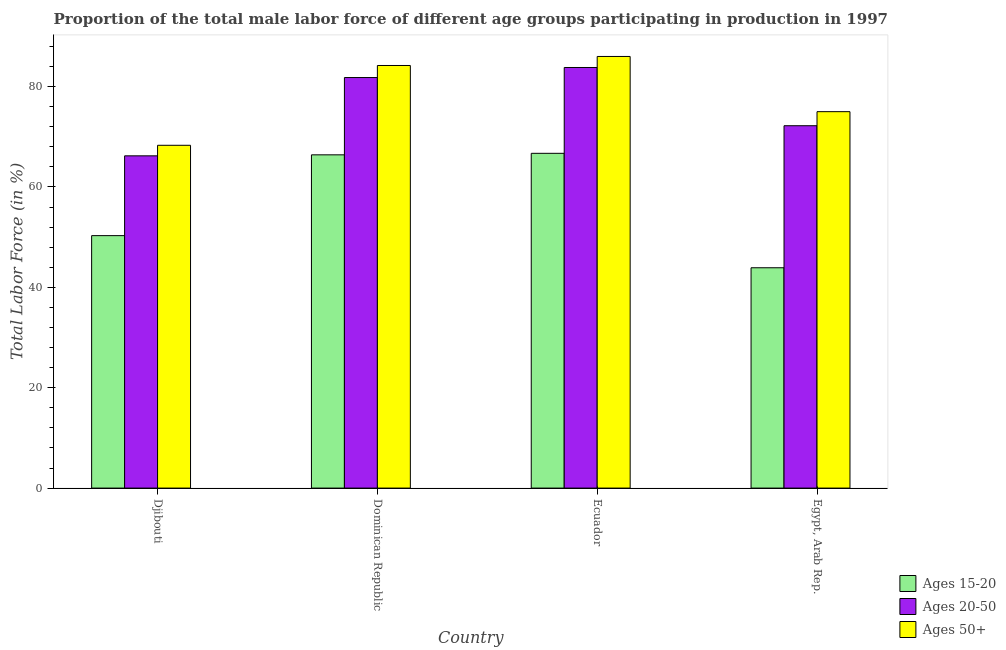How many bars are there on the 1st tick from the right?
Make the answer very short. 3. What is the label of the 1st group of bars from the left?
Provide a short and direct response. Djibouti. In how many cases, is the number of bars for a given country not equal to the number of legend labels?
Keep it short and to the point. 0. What is the percentage of male labor force above age 50 in Dominican Republic?
Ensure brevity in your answer.  84.2. Across all countries, what is the maximum percentage of male labor force within the age group 20-50?
Provide a short and direct response. 83.8. Across all countries, what is the minimum percentage of male labor force above age 50?
Provide a succinct answer. 68.3. In which country was the percentage of male labor force within the age group 15-20 maximum?
Offer a very short reply. Ecuador. In which country was the percentage of male labor force within the age group 20-50 minimum?
Give a very brief answer. Djibouti. What is the total percentage of male labor force within the age group 20-50 in the graph?
Keep it short and to the point. 304. What is the difference between the percentage of male labor force within the age group 15-20 in Ecuador and that in Egypt, Arab Rep.?
Ensure brevity in your answer.  22.8. What is the difference between the percentage of male labor force within the age group 15-20 in Egypt, Arab Rep. and the percentage of male labor force above age 50 in Dominican Republic?
Your response must be concise. -40.3. What is the average percentage of male labor force above age 50 per country?
Offer a very short reply. 78.38. What is the difference between the percentage of male labor force within the age group 15-20 and percentage of male labor force within the age group 20-50 in Ecuador?
Make the answer very short. -17.1. What is the ratio of the percentage of male labor force within the age group 20-50 in Dominican Republic to that in Ecuador?
Ensure brevity in your answer.  0.98. Is the percentage of male labor force above age 50 in Djibouti less than that in Ecuador?
Offer a terse response. Yes. Is the difference between the percentage of male labor force above age 50 in Djibouti and Ecuador greater than the difference between the percentage of male labor force within the age group 15-20 in Djibouti and Ecuador?
Offer a terse response. No. What is the difference between the highest and the second highest percentage of male labor force above age 50?
Provide a succinct answer. 1.8. What is the difference between the highest and the lowest percentage of male labor force within the age group 15-20?
Your response must be concise. 22.8. In how many countries, is the percentage of male labor force within the age group 20-50 greater than the average percentage of male labor force within the age group 20-50 taken over all countries?
Ensure brevity in your answer.  2. What does the 1st bar from the left in Ecuador represents?
Make the answer very short. Ages 15-20. What does the 2nd bar from the right in Ecuador represents?
Your answer should be compact. Ages 20-50. Is it the case that in every country, the sum of the percentage of male labor force within the age group 15-20 and percentage of male labor force within the age group 20-50 is greater than the percentage of male labor force above age 50?
Ensure brevity in your answer.  Yes. How many bars are there?
Your answer should be very brief. 12. How many countries are there in the graph?
Offer a very short reply. 4. What is the difference between two consecutive major ticks on the Y-axis?
Your answer should be very brief. 20. Are the values on the major ticks of Y-axis written in scientific E-notation?
Give a very brief answer. No. Does the graph contain any zero values?
Your response must be concise. No. Where does the legend appear in the graph?
Keep it short and to the point. Bottom right. How are the legend labels stacked?
Ensure brevity in your answer.  Vertical. What is the title of the graph?
Your answer should be very brief. Proportion of the total male labor force of different age groups participating in production in 1997. Does "Central government" appear as one of the legend labels in the graph?
Keep it short and to the point. No. What is the label or title of the X-axis?
Your answer should be compact. Country. What is the Total Labor Force (in %) of Ages 15-20 in Djibouti?
Ensure brevity in your answer.  50.3. What is the Total Labor Force (in %) of Ages 20-50 in Djibouti?
Offer a terse response. 66.2. What is the Total Labor Force (in %) in Ages 50+ in Djibouti?
Give a very brief answer. 68.3. What is the Total Labor Force (in %) in Ages 15-20 in Dominican Republic?
Provide a short and direct response. 66.4. What is the Total Labor Force (in %) of Ages 20-50 in Dominican Republic?
Provide a succinct answer. 81.8. What is the Total Labor Force (in %) in Ages 50+ in Dominican Republic?
Ensure brevity in your answer.  84.2. What is the Total Labor Force (in %) in Ages 15-20 in Ecuador?
Ensure brevity in your answer.  66.7. What is the Total Labor Force (in %) in Ages 20-50 in Ecuador?
Provide a succinct answer. 83.8. What is the Total Labor Force (in %) in Ages 15-20 in Egypt, Arab Rep.?
Provide a succinct answer. 43.9. What is the Total Labor Force (in %) of Ages 20-50 in Egypt, Arab Rep.?
Offer a very short reply. 72.2. What is the Total Labor Force (in %) of Ages 50+ in Egypt, Arab Rep.?
Ensure brevity in your answer.  75. Across all countries, what is the maximum Total Labor Force (in %) in Ages 15-20?
Keep it short and to the point. 66.7. Across all countries, what is the maximum Total Labor Force (in %) in Ages 20-50?
Provide a short and direct response. 83.8. Across all countries, what is the minimum Total Labor Force (in %) in Ages 15-20?
Your response must be concise. 43.9. Across all countries, what is the minimum Total Labor Force (in %) of Ages 20-50?
Provide a succinct answer. 66.2. Across all countries, what is the minimum Total Labor Force (in %) in Ages 50+?
Offer a very short reply. 68.3. What is the total Total Labor Force (in %) in Ages 15-20 in the graph?
Provide a succinct answer. 227.3. What is the total Total Labor Force (in %) of Ages 20-50 in the graph?
Your answer should be very brief. 304. What is the total Total Labor Force (in %) of Ages 50+ in the graph?
Your response must be concise. 313.5. What is the difference between the Total Labor Force (in %) in Ages 15-20 in Djibouti and that in Dominican Republic?
Offer a very short reply. -16.1. What is the difference between the Total Labor Force (in %) in Ages 20-50 in Djibouti and that in Dominican Republic?
Ensure brevity in your answer.  -15.6. What is the difference between the Total Labor Force (in %) in Ages 50+ in Djibouti and that in Dominican Republic?
Offer a very short reply. -15.9. What is the difference between the Total Labor Force (in %) of Ages 15-20 in Djibouti and that in Ecuador?
Offer a terse response. -16.4. What is the difference between the Total Labor Force (in %) of Ages 20-50 in Djibouti and that in Ecuador?
Give a very brief answer. -17.6. What is the difference between the Total Labor Force (in %) in Ages 50+ in Djibouti and that in Ecuador?
Offer a terse response. -17.7. What is the difference between the Total Labor Force (in %) of Ages 15-20 in Dominican Republic and that in Ecuador?
Make the answer very short. -0.3. What is the difference between the Total Labor Force (in %) in Ages 20-50 in Dominican Republic and that in Egypt, Arab Rep.?
Provide a succinct answer. 9.6. What is the difference between the Total Labor Force (in %) in Ages 15-20 in Ecuador and that in Egypt, Arab Rep.?
Ensure brevity in your answer.  22.8. What is the difference between the Total Labor Force (in %) in Ages 50+ in Ecuador and that in Egypt, Arab Rep.?
Make the answer very short. 11. What is the difference between the Total Labor Force (in %) of Ages 15-20 in Djibouti and the Total Labor Force (in %) of Ages 20-50 in Dominican Republic?
Offer a terse response. -31.5. What is the difference between the Total Labor Force (in %) of Ages 15-20 in Djibouti and the Total Labor Force (in %) of Ages 50+ in Dominican Republic?
Offer a very short reply. -33.9. What is the difference between the Total Labor Force (in %) in Ages 20-50 in Djibouti and the Total Labor Force (in %) in Ages 50+ in Dominican Republic?
Offer a terse response. -18. What is the difference between the Total Labor Force (in %) in Ages 15-20 in Djibouti and the Total Labor Force (in %) in Ages 20-50 in Ecuador?
Keep it short and to the point. -33.5. What is the difference between the Total Labor Force (in %) in Ages 15-20 in Djibouti and the Total Labor Force (in %) in Ages 50+ in Ecuador?
Your response must be concise. -35.7. What is the difference between the Total Labor Force (in %) in Ages 20-50 in Djibouti and the Total Labor Force (in %) in Ages 50+ in Ecuador?
Offer a terse response. -19.8. What is the difference between the Total Labor Force (in %) of Ages 15-20 in Djibouti and the Total Labor Force (in %) of Ages 20-50 in Egypt, Arab Rep.?
Provide a succinct answer. -21.9. What is the difference between the Total Labor Force (in %) of Ages 15-20 in Djibouti and the Total Labor Force (in %) of Ages 50+ in Egypt, Arab Rep.?
Offer a very short reply. -24.7. What is the difference between the Total Labor Force (in %) in Ages 15-20 in Dominican Republic and the Total Labor Force (in %) in Ages 20-50 in Ecuador?
Provide a short and direct response. -17.4. What is the difference between the Total Labor Force (in %) of Ages 15-20 in Dominican Republic and the Total Labor Force (in %) of Ages 50+ in Ecuador?
Your response must be concise. -19.6. What is the difference between the Total Labor Force (in %) of Ages 15-20 in Dominican Republic and the Total Labor Force (in %) of Ages 20-50 in Egypt, Arab Rep.?
Keep it short and to the point. -5.8. What is the difference between the Total Labor Force (in %) in Ages 15-20 in Dominican Republic and the Total Labor Force (in %) in Ages 50+ in Egypt, Arab Rep.?
Your response must be concise. -8.6. What is the difference between the Total Labor Force (in %) of Ages 20-50 in Dominican Republic and the Total Labor Force (in %) of Ages 50+ in Egypt, Arab Rep.?
Ensure brevity in your answer.  6.8. What is the difference between the Total Labor Force (in %) in Ages 15-20 in Ecuador and the Total Labor Force (in %) in Ages 20-50 in Egypt, Arab Rep.?
Offer a terse response. -5.5. What is the difference between the Total Labor Force (in %) in Ages 15-20 in Ecuador and the Total Labor Force (in %) in Ages 50+ in Egypt, Arab Rep.?
Give a very brief answer. -8.3. What is the difference between the Total Labor Force (in %) of Ages 20-50 in Ecuador and the Total Labor Force (in %) of Ages 50+ in Egypt, Arab Rep.?
Ensure brevity in your answer.  8.8. What is the average Total Labor Force (in %) in Ages 15-20 per country?
Keep it short and to the point. 56.83. What is the average Total Labor Force (in %) in Ages 20-50 per country?
Your answer should be compact. 76. What is the average Total Labor Force (in %) in Ages 50+ per country?
Your answer should be compact. 78.38. What is the difference between the Total Labor Force (in %) in Ages 15-20 and Total Labor Force (in %) in Ages 20-50 in Djibouti?
Provide a short and direct response. -15.9. What is the difference between the Total Labor Force (in %) in Ages 15-20 and Total Labor Force (in %) in Ages 20-50 in Dominican Republic?
Ensure brevity in your answer.  -15.4. What is the difference between the Total Labor Force (in %) of Ages 15-20 and Total Labor Force (in %) of Ages 50+ in Dominican Republic?
Keep it short and to the point. -17.8. What is the difference between the Total Labor Force (in %) of Ages 20-50 and Total Labor Force (in %) of Ages 50+ in Dominican Republic?
Give a very brief answer. -2.4. What is the difference between the Total Labor Force (in %) in Ages 15-20 and Total Labor Force (in %) in Ages 20-50 in Ecuador?
Provide a short and direct response. -17.1. What is the difference between the Total Labor Force (in %) of Ages 15-20 and Total Labor Force (in %) of Ages 50+ in Ecuador?
Keep it short and to the point. -19.3. What is the difference between the Total Labor Force (in %) of Ages 20-50 and Total Labor Force (in %) of Ages 50+ in Ecuador?
Give a very brief answer. -2.2. What is the difference between the Total Labor Force (in %) of Ages 15-20 and Total Labor Force (in %) of Ages 20-50 in Egypt, Arab Rep.?
Ensure brevity in your answer.  -28.3. What is the difference between the Total Labor Force (in %) in Ages 15-20 and Total Labor Force (in %) in Ages 50+ in Egypt, Arab Rep.?
Give a very brief answer. -31.1. What is the ratio of the Total Labor Force (in %) in Ages 15-20 in Djibouti to that in Dominican Republic?
Ensure brevity in your answer.  0.76. What is the ratio of the Total Labor Force (in %) in Ages 20-50 in Djibouti to that in Dominican Republic?
Your response must be concise. 0.81. What is the ratio of the Total Labor Force (in %) in Ages 50+ in Djibouti to that in Dominican Republic?
Offer a terse response. 0.81. What is the ratio of the Total Labor Force (in %) of Ages 15-20 in Djibouti to that in Ecuador?
Provide a succinct answer. 0.75. What is the ratio of the Total Labor Force (in %) of Ages 20-50 in Djibouti to that in Ecuador?
Offer a very short reply. 0.79. What is the ratio of the Total Labor Force (in %) of Ages 50+ in Djibouti to that in Ecuador?
Provide a short and direct response. 0.79. What is the ratio of the Total Labor Force (in %) in Ages 15-20 in Djibouti to that in Egypt, Arab Rep.?
Offer a terse response. 1.15. What is the ratio of the Total Labor Force (in %) of Ages 20-50 in Djibouti to that in Egypt, Arab Rep.?
Your answer should be compact. 0.92. What is the ratio of the Total Labor Force (in %) of Ages 50+ in Djibouti to that in Egypt, Arab Rep.?
Make the answer very short. 0.91. What is the ratio of the Total Labor Force (in %) of Ages 20-50 in Dominican Republic to that in Ecuador?
Provide a short and direct response. 0.98. What is the ratio of the Total Labor Force (in %) of Ages 50+ in Dominican Republic to that in Ecuador?
Ensure brevity in your answer.  0.98. What is the ratio of the Total Labor Force (in %) in Ages 15-20 in Dominican Republic to that in Egypt, Arab Rep.?
Ensure brevity in your answer.  1.51. What is the ratio of the Total Labor Force (in %) of Ages 20-50 in Dominican Republic to that in Egypt, Arab Rep.?
Your response must be concise. 1.13. What is the ratio of the Total Labor Force (in %) in Ages 50+ in Dominican Republic to that in Egypt, Arab Rep.?
Ensure brevity in your answer.  1.12. What is the ratio of the Total Labor Force (in %) in Ages 15-20 in Ecuador to that in Egypt, Arab Rep.?
Your answer should be very brief. 1.52. What is the ratio of the Total Labor Force (in %) in Ages 20-50 in Ecuador to that in Egypt, Arab Rep.?
Your answer should be very brief. 1.16. What is the ratio of the Total Labor Force (in %) in Ages 50+ in Ecuador to that in Egypt, Arab Rep.?
Give a very brief answer. 1.15. What is the difference between the highest and the second highest Total Labor Force (in %) of Ages 15-20?
Offer a terse response. 0.3. What is the difference between the highest and the second highest Total Labor Force (in %) of Ages 20-50?
Keep it short and to the point. 2. What is the difference between the highest and the lowest Total Labor Force (in %) of Ages 15-20?
Offer a terse response. 22.8. 